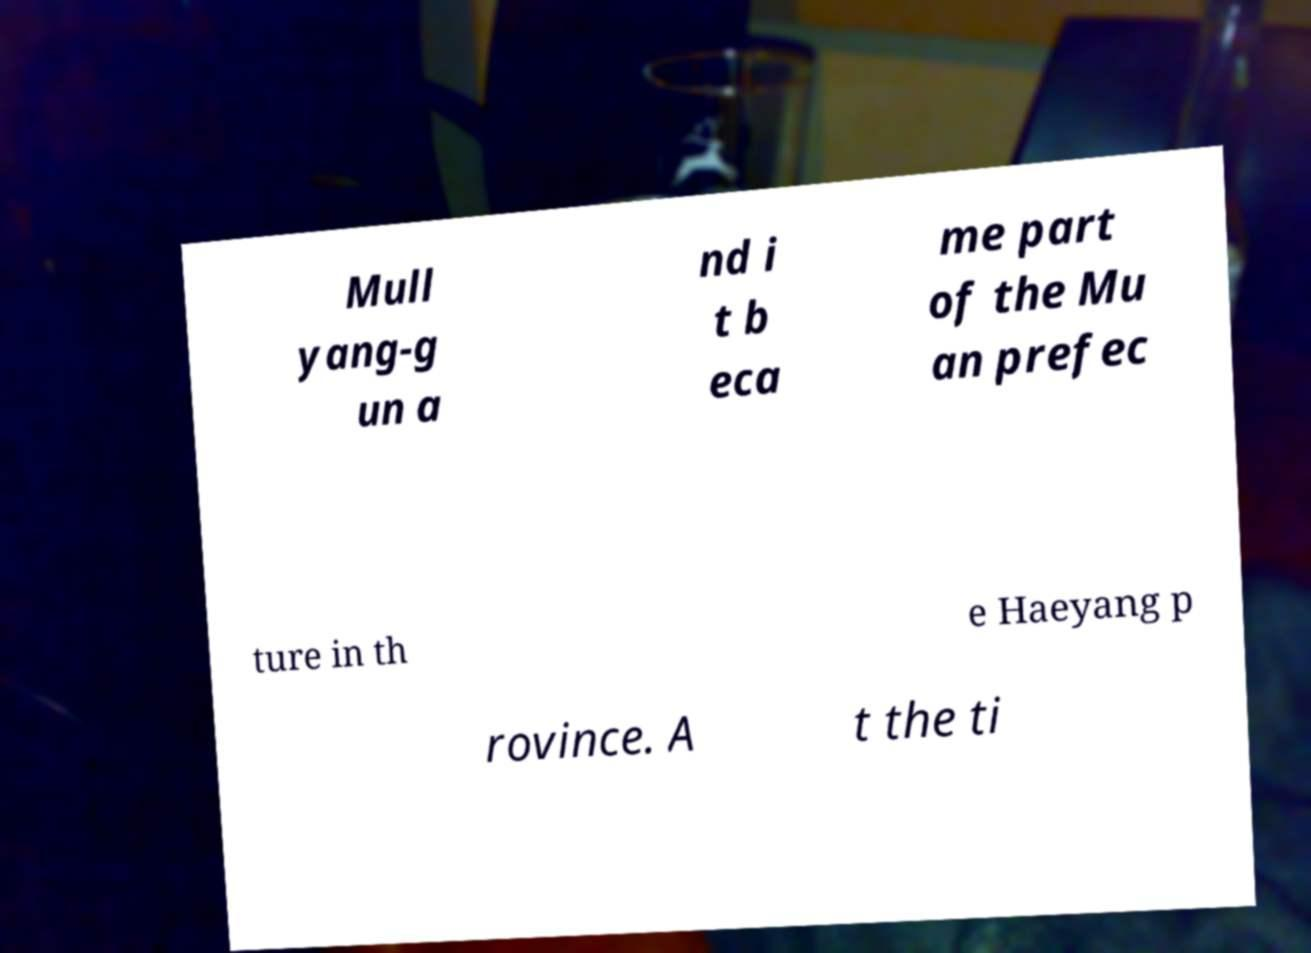Can you read and provide the text displayed in the image?This photo seems to have some interesting text. Can you extract and type it out for me? Mull yang-g un a nd i t b eca me part of the Mu an prefec ture in th e Haeyang p rovince. A t the ti 